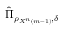<formula> <loc_0><loc_0><loc_500><loc_500>{ \hat { \Pi } } _ { \rho _ { X ^ { n } \left ( m - 1 \right ) } , \delta }</formula> 